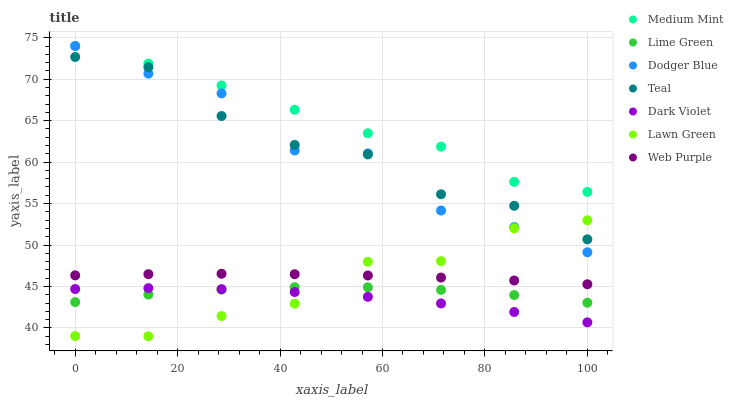Does Dark Violet have the minimum area under the curve?
Answer yes or no. Yes. Does Medium Mint have the maximum area under the curve?
Answer yes or no. Yes. Does Lawn Green have the minimum area under the curve?
Answer yes or no. No. Does Lawn Green have the maximum area under the curve?
Answer yes or no. No. Is Web Purple the smoothest?
Answer yes or no. Yes. Is Dodger Blue the roughest?
Answer yes or no. Yes. Is Lawn Green the smoothest?
Answer yes or no. No. Is Lawn Green the roughest?
Answer yes or no. No. Does Lawn Green have the lowest value?
Answer yes or no. Yes. Does Dark Violet have the lowest value?
Answer yes or no. No. Does Dodger Blue have the highest value?
Answer yes or no. Yes. Does Lawn Green have the highest value?
Answer yes or no. No. Is Web Purple less than Teal?
Answer yes or no. Yes. Is Medium Mint greater than Dark Violet?
Answer yes or no. Yes. Does Lime Green intersect Dark Violet?
Answer yes or no. Yes. Is Lime Green less than Dark Violet?
Answer yes or no. No. Is Lime Green greater than Dark Violet?
Answer yes or no. No. Does Web Purple intersect Teal?
Answer yes or no. No. 